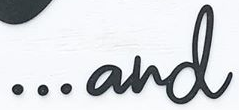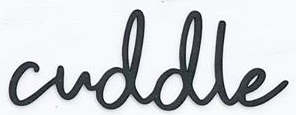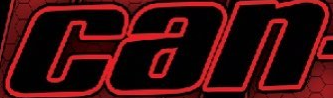Read the text content from these images in order, separated by a semicolon. ...and; cuddle; can 